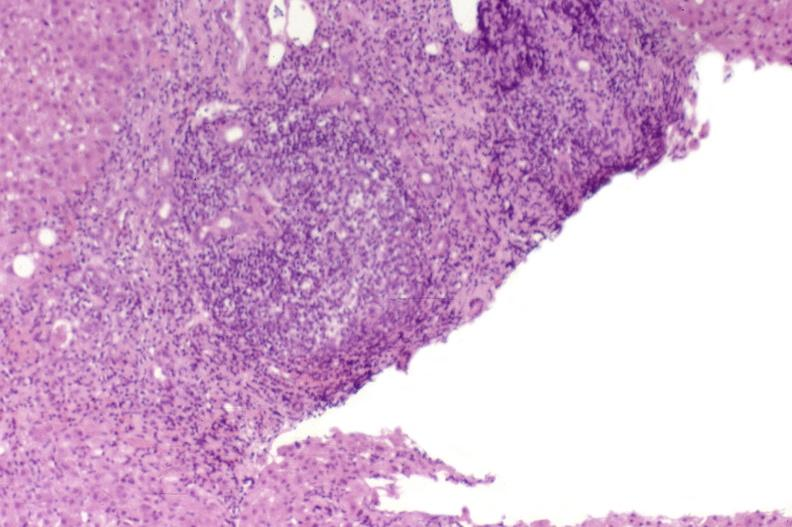what does this image show?
Answer the question using a single word or phrase. Recurrent hepatitis c virus 